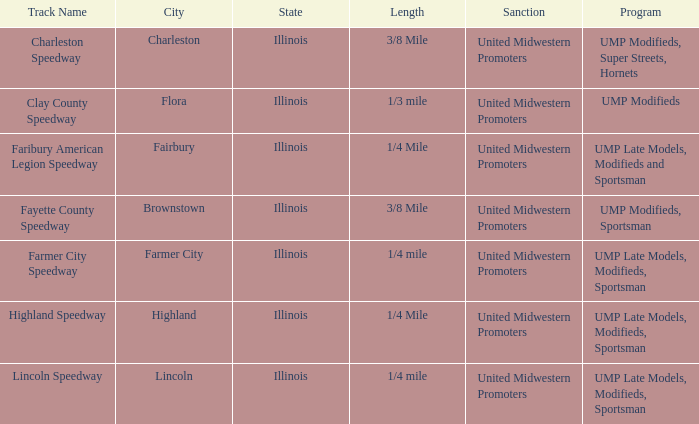Who sanctioned the event at fayette county speedway? United Midwestern Promoters. 